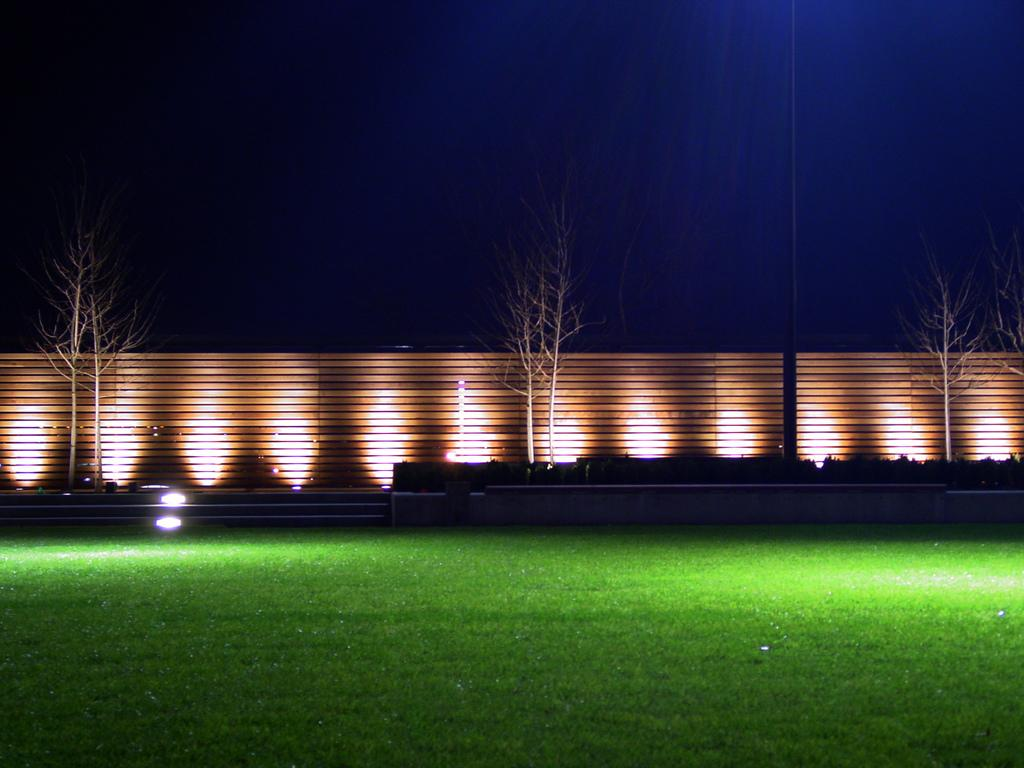What type of vegetation can be seen in the image? There is green grass in the image. What kind of barrier is present in the image? There is a wooden fence in the image. What can be seen illuminating the area in the image? Lights are visible in the image. What is visible in the sky in the image? Clouds are present in the sky in the image. What type of instrument is being played by the grass in the image? There is no instrument being played by the grass in the image, as grass is a plant and does not have the ability to play instruments. 